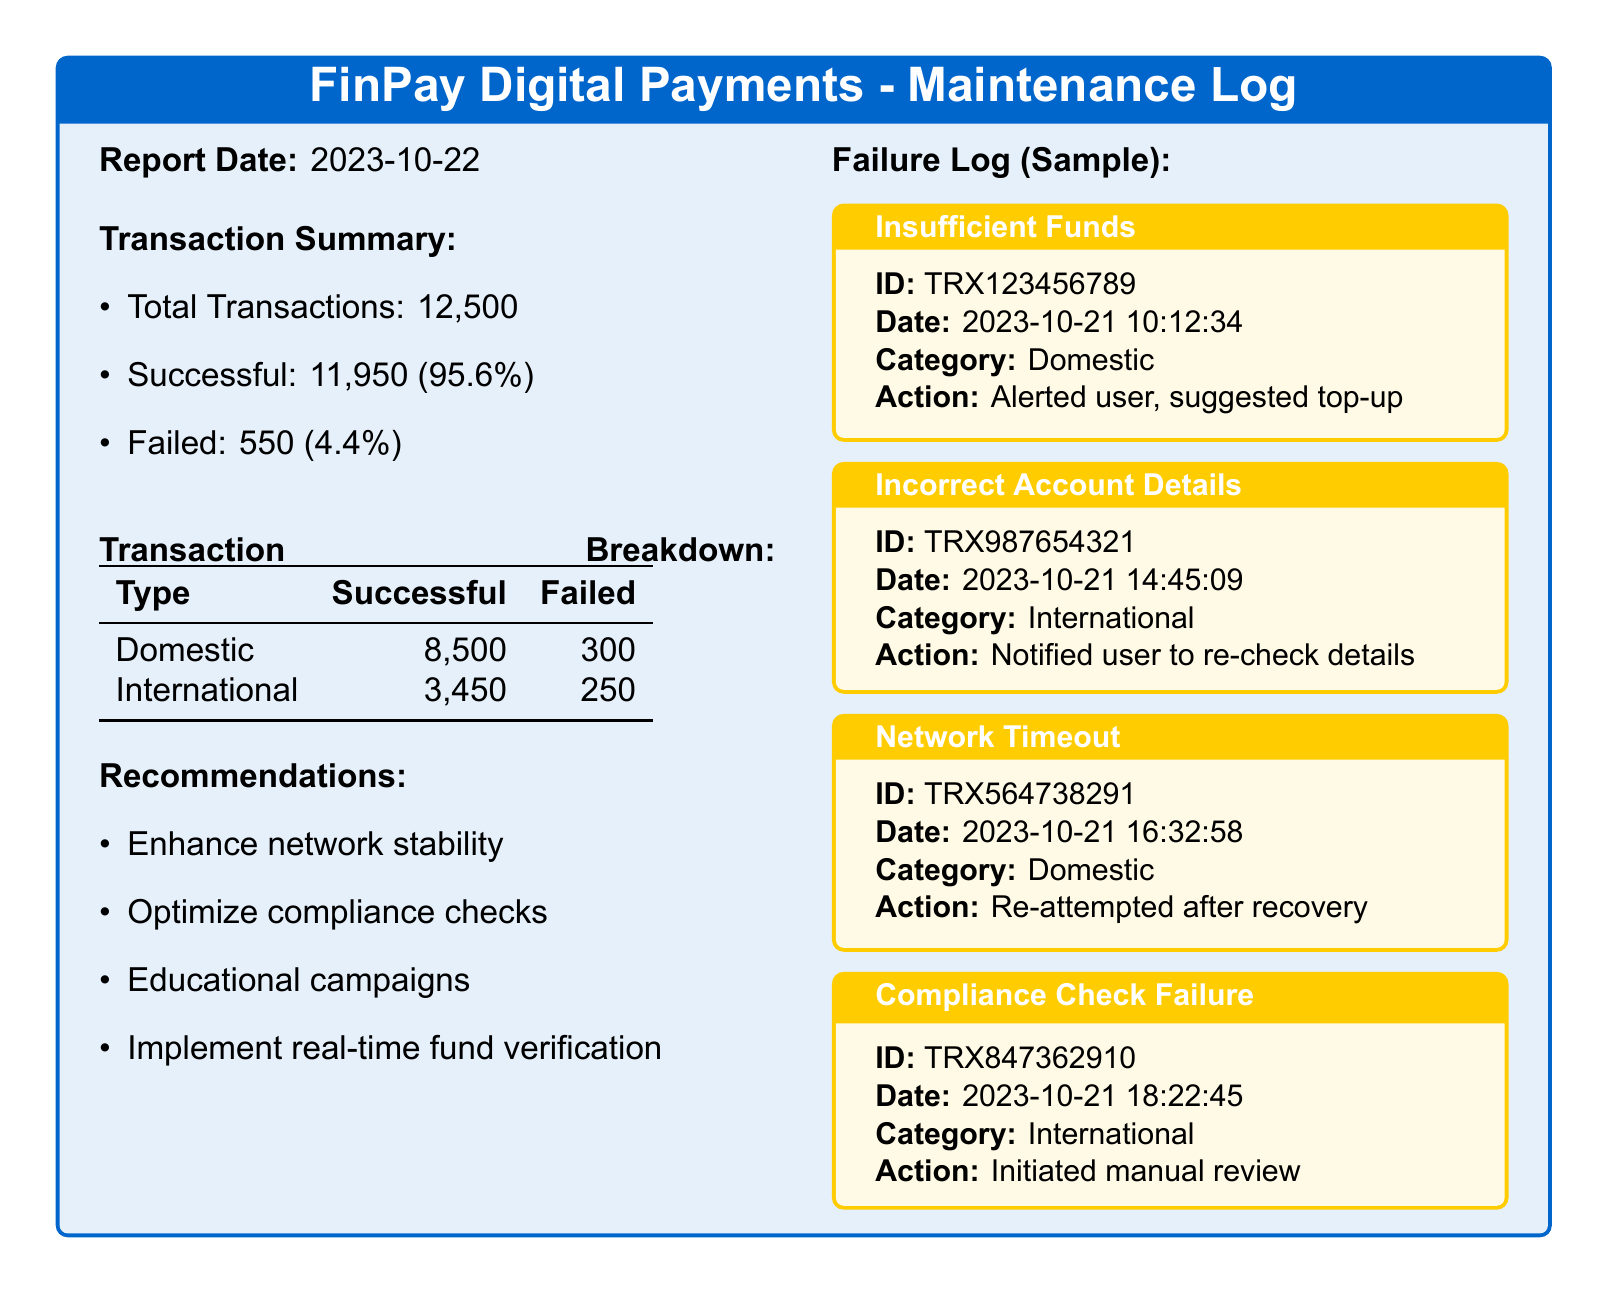What is the total number of transactions? The total number of transactions is mentioned in the transaction summary, which lists it as 12,500.
Answer: 12,500 What percentage of transactions were successful? The document states that successful transactions are 11,950 out of 12,500, which is calculated to be 95.6%.
Answer: 95.6% How many failed international transactions were reported? The transaction breakdown table indicates that there were 250 failed international transactions.
Answer: 250 What was the action taken for the transaction ID TRX123456789? The action taken for this transaction, which failed due to insufficient funds, was to alert the user and suggest a top-up.
Answer: Alerted user, suggested top-up What is one of the recommendations made in the report? One of the recommendations provided in the document is to enhance network stability.
Answer: Enhance network stability How many failed domestic transactions were processed? According to the transaction breakdown, the document shows there were 300 failed domestic transactions.
Answer: 300 What was the reason for transaction failure for TRX847362910? The failure reason for this transaction was a compliance check failure, as specified in the document.
Answer: Compliance Check Failure What action followed the network timeout for TRX564738291? The action taken after the network timeout for this transaction was to re-attempt after recovery.
Answer: Re-attempted after recovery 